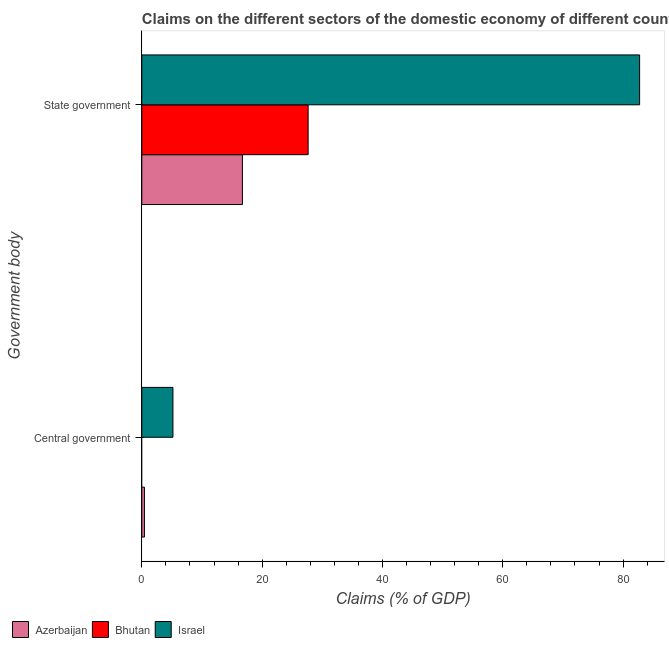How many different coloured bars are there?
Offer a terse response. 3. How many groups of bars are there?
Give a very brief answer. 2. How many bars are there on the 2nd tick from the bottom?
Ensure brevity in your answer.  3. What is the label of the 2nd group of bars from the top?
Your answer should be compact. Central government. What is the claims on state government in Azerbaijan?
Provide a short and direct response. 16.73. Across all countries, what is the maximum claims on central government?
Provide a short and direct response. 5.18. Across all countries, what is the minimum claims on state government?
Your answer should be very brief. 16.73. What is the total claims on state government in the graph?
Offer a terse response. 127.12. What is the difference between the claims on state government in Israel and that in Azerbaijan?
Offer a terse response. 66.02. What is the difference between the claims on state government in Azerbaijan and the claims on central government in Israel?
Your answer should be very brief. 11.55. What is the average claims on central government per country?
Ensure brevity in your answer.  1.87. What is the difference between the claims on state government and claims on central government in Israel?
Your answer should be very brief. 77.57. What is the ratio of the claims on central government in Azerbaijan to that in Israel?
Offer a terse response. 0.08. In how many countries, is the claims on state government greater than the average claims on state government taken over all countries?
Offer a terse response. 1. How many bars are there?
Provide a short and direct response. 5. Are all the bars in the graph horizontal?
Ensure brevity in your answer.  Yes. What is the difference between two consecutive major ticks on the X-axis?
Offer a very short reply. 20. Does the graph contain any zero values?
Provide a short and direct response. Yes. Does the graph contain grids?
Ensure brevity in your answer.  No. How many legend labels are there?
Your answer should be compact. 3. What is the title of the graph?
Keep it short and to the point. Claims on the different sectors of the domestic economy of different countries. What is the label or title of the X-axis?
Keep it short and to the point. Claims (% of GDP). What is the label or title of the Y-axis?
Keep it short and to the point. Government body. What is the Claims (% of GDP) in Azerbaijan in Central government?
Your answer should be compact. 0.44. What is the Claims (% of GDP) of Israel in Central government?
Give a very brief answer. 5.18. What is the Claims (% of GDP) of Azerbaijan in State government?
Ensure brevity in your answer.  16.73. What is the Claims (% of GDP) in Bhutan in State government?
Offer a terse response. 27.65. What is the Claims (% of GDP) of Israel in State government?
Your response must be concise. 82.75. Across all Government body, what is the maximum Claims (% of GDP) of Azerbaijan?
Offer a terse response. 16.73. Across all Government body, what is the maximum Claims (% of GDP) of Bhutan?
Your answer should be compact. 27.65. Across all Government body, what is the maximum Claims (% of GDP) of Israel?
Provide a short and direct response. 82.75. Across all Government body, what is the minimum Claims (% of GDP) in Azerbaijan?
Offer a very short reply. 0.44. Across all Government body, what is the minimum Claims (% of GDP) in Bhutan?
Provide a succinct answer. 0. Across all Government body, what is the minimum Claims (% of GDP) of Israel?
Your answer should be compact. 5.18. What is the total Claims (% of GDP) of Azerbaijan in the graph?
Your response must be concise. 17.16. What is the total Claims (% of GDP) in Bhutan in the graph?
Ensure brevity in your answer.  27.65. What is the total Claims (% of GDP) in Israel in the graph?
Your answer should be compact. 87.92. What is the difference between the Claims (% of GDP) of Azerbaijan in Central government and that in State government?
Provide a short and direct response. -16.29. What is the difference between the Claims (% of GDP) in Israel in Central government and that in State government?
Ensure brevity in your answer.  -77.57. What is the difference between the Claims (% of GDP) in Azerbaijan in Central government and the Claims (% of GDP) in Bhutan in State government?
Provide a short and direct response. -27.21. What is the difference between the Claims (% of GDP) in Azerbaijan in Central government and the Claims (% of GDP) in Israel in State government?
Provide a short and direct response. -82.31. What is the average Claims (% of GDP) of Azerbaijan per Government body?
Ensure brevity in your answer.  8.58. What is the average Claims (% of GDP) of Bhutan per Government body?
Your answer should be very brief. 13.82. What is the average Claims (% of GDP) of Israel per Government body?
Offer a very short reply. 43.96. What is the difference between the Claims (% of GDP) in Azerbaijan and Claims (% of GDP) in Israel in Central government?
Provide a succinct answer. -4.74. What is the difference between the Claims (% of GDP) of Azerbaijan and Claims (% of GDP) of Bhutan in State government?
Your response must be concise. -10.92. What is the difference between the Claims (% of GDP) in Azerbaijan and Claims (% of GDP) in Israel in State government?
Give a very brief answer. -66.02. What is the difference between the Claims (% of GDP) in Bhutan and Claims (% of GDP) in Israel in State government?
Your response must be concise. -55.1. What is the ratio of the Claims (% of GDP) of Azerbaijan in Central government to that in State government?
Offer a very short reply. 0.03. What is the ratio of the Claims (% of GDP) of Israel in Central government to that in State government?
Your answer should be compact. 0.06. What is the difference between the highest and the second highest Claims (% of GDP) of Azerbaijan?
Offer a very short reply. 16.29. What is the difference between the highest and the second highest Claims (% of GDP) in Israel?
Make the answer very short. 77.57. What is the difference between the highest and the lowest Claims (% of GDP) of Azerbaijan?
Keep it short and to the point. 16.29. What is the difference between the highest and the lowest Claims (% of GDP) of Bhutan?
Make the answer very short. 27.65. What is the difference between the highest and the lowest Claims (% of GDP) in Israel?
Ensure brevity in your answer.  77.57. 